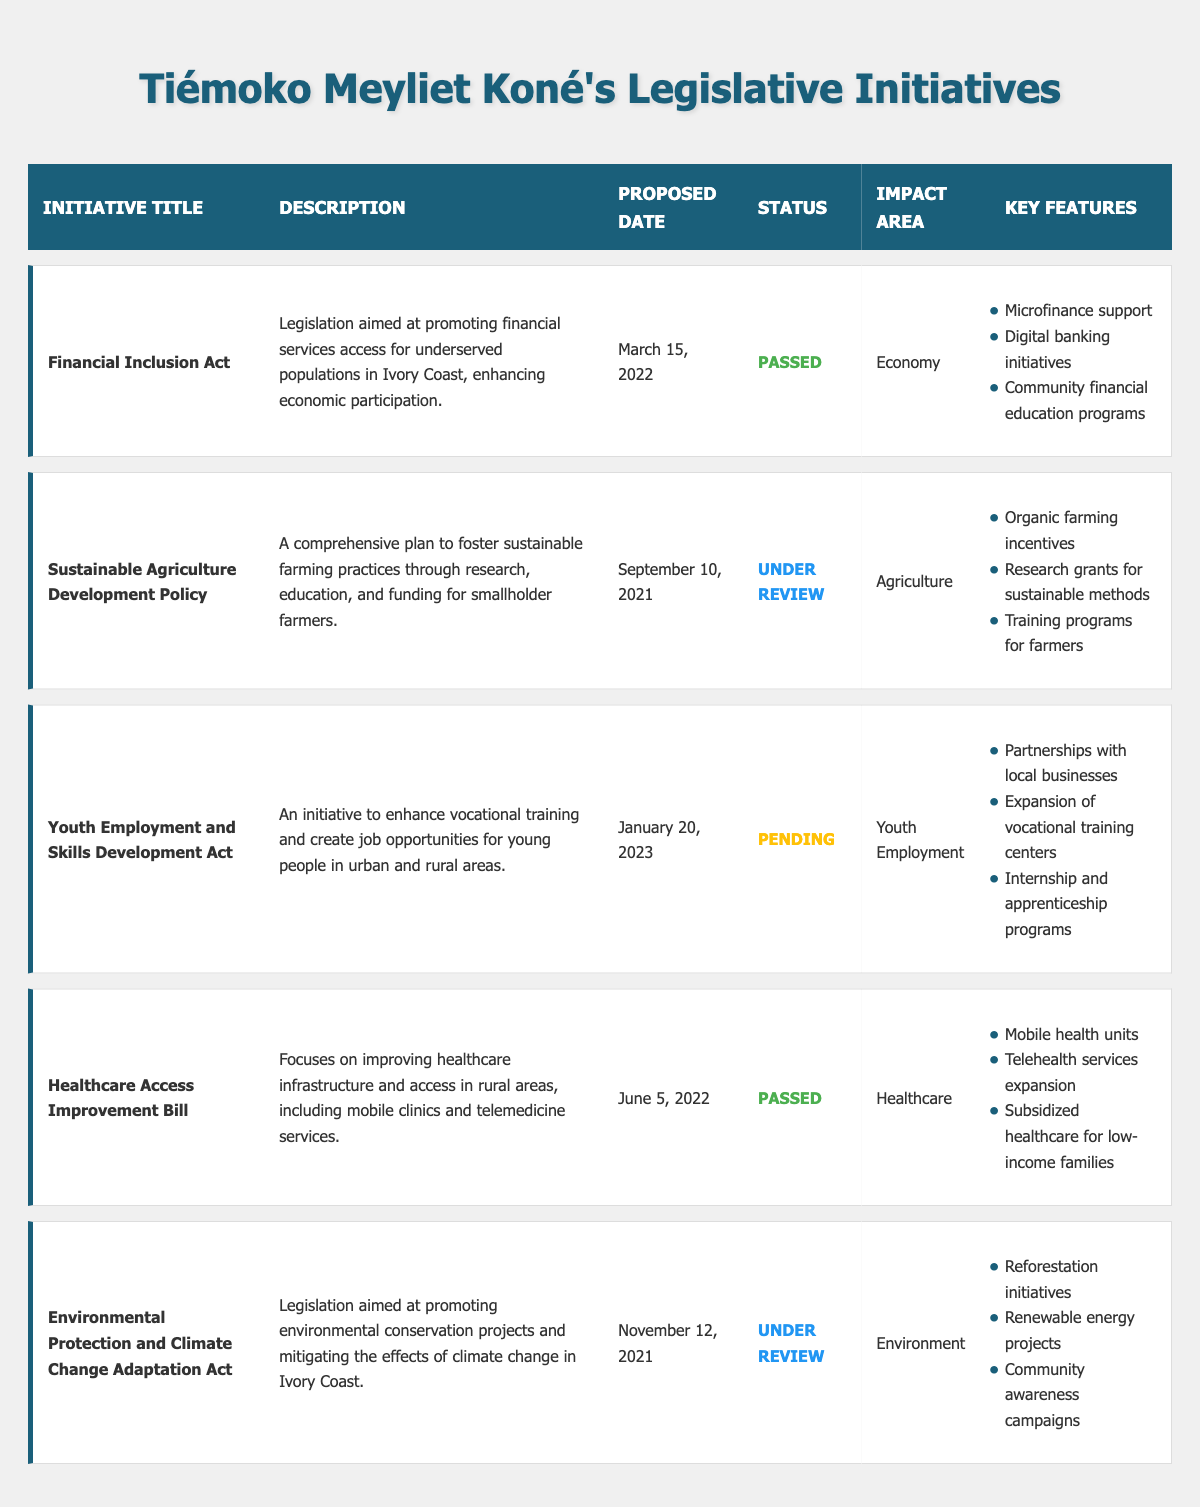What is the title of the initiative proposed on March 15, 2022? The table indicates that the initiative proposed on March 15, 2022, is titled "Financial Inclusion Act." I locate the proposed date in the table and find the corresponding initiative title in the same row.
Answer: Financial Inclusion Act How many initiatives are currently under review? The table shows two initiatives marked as "Under Review," which are the "Sustainable Agriculture Development Policy" and the "Environmental Protection and Climate Change Adaptation Act." I count the entries in the status column that match "Under Review."
Answer: 2 Did the "Healthcare Access Improvement Bill" pass? According to the table, the status of the "Healthcare Access Improvement Bill" is marked as "Passed." I can directly find this information in the status column corresponding to this initiative.
Answer: Yes What are the key features of the "Financial Inclusion Act"? The key features of the "Financial Inclusion Act," as found in the table, include microfinance support, digital banking initiatives, and community financial education programs. I refer to the key features section for this initiative to extract the list.
Answer: Microfinance support, digital banking initiatives, community financial education programs What is the difference in the proposed dates between the "Sustainable Agriculture Development Policy" and the "Youth Employment and Skills Development Act"? The "Sustainable Agriculture Development Policy" is proposed on September 10, 2021, and the "Youth Employment and Skills Development Act" is proposed on January 20, 2023. Calculating the difference, there are 1 year and 4 months or 16 months between these dates. I find the respective dates in the table and determine the difference.
Answer: 16 months What initiative was proposed most recently? The most recent initiative in the table is the "Youth Employment and Skills Development Act," proposed on January 20, 2023. I compare all the proposed dates in the table to identify the latest one.
Answer: Youth Employment and Skills Development Act How many initiatives focus on the impact area of "Economy"? The table shows that only one initiative, the "Financial Inclusion Act," focuses on the impact area of the economy. I review the impact area column for each initiative to determine how many refer to "Economy."
Answer: 1 Is there any initiative related to environmental conservation? Yes, the "Environmental Protection and Climate Change Adaptation Act" focuses on environmental conservation, as indicated in the impact area column. I simply check the entries related to the environmental impact to answer this question.
Answer: Yes What key feature is associated with the "Youth Employment and Skills Development Act"? One of the key features associated with the "Youth Employment and Skills Development Act" is partnerships with local businesses. I refer to the key features listed under this specific initiative to identify it.
Answer: Partnerships with local businesses 